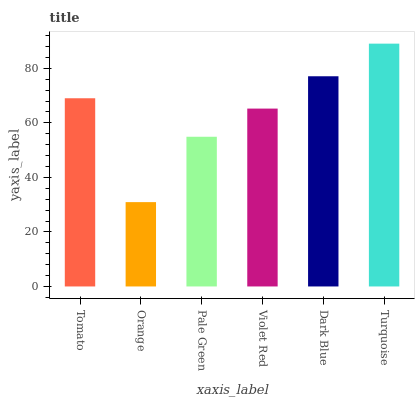Is Orange the minimum?
Answer yes or no. Yes. Is Turquoise the maximum?
Answer yes or no. Yes. Is Pale Green the minimum?
Answer yes or no. No. Is Pale Green the maximum?
Answer yes or no. No. Is Pale Green greater than Orange?
Answer yes or no. Yes. Is Orange less than Pale Green?
Answer yes or no. Yes. Is Orange greater than Pale Green?
Answer yes or no. No. Is Pale Green less than Orange?
Answer yes or no. No. Is Tomato the high median?
Answer yes or no. Yes. Is Violet Red the low median?
Answer yes or no. Yes. Is Orange the high median?
Answer yes or no. No. Is Tomato the low median?
Answer yes or no. No. 